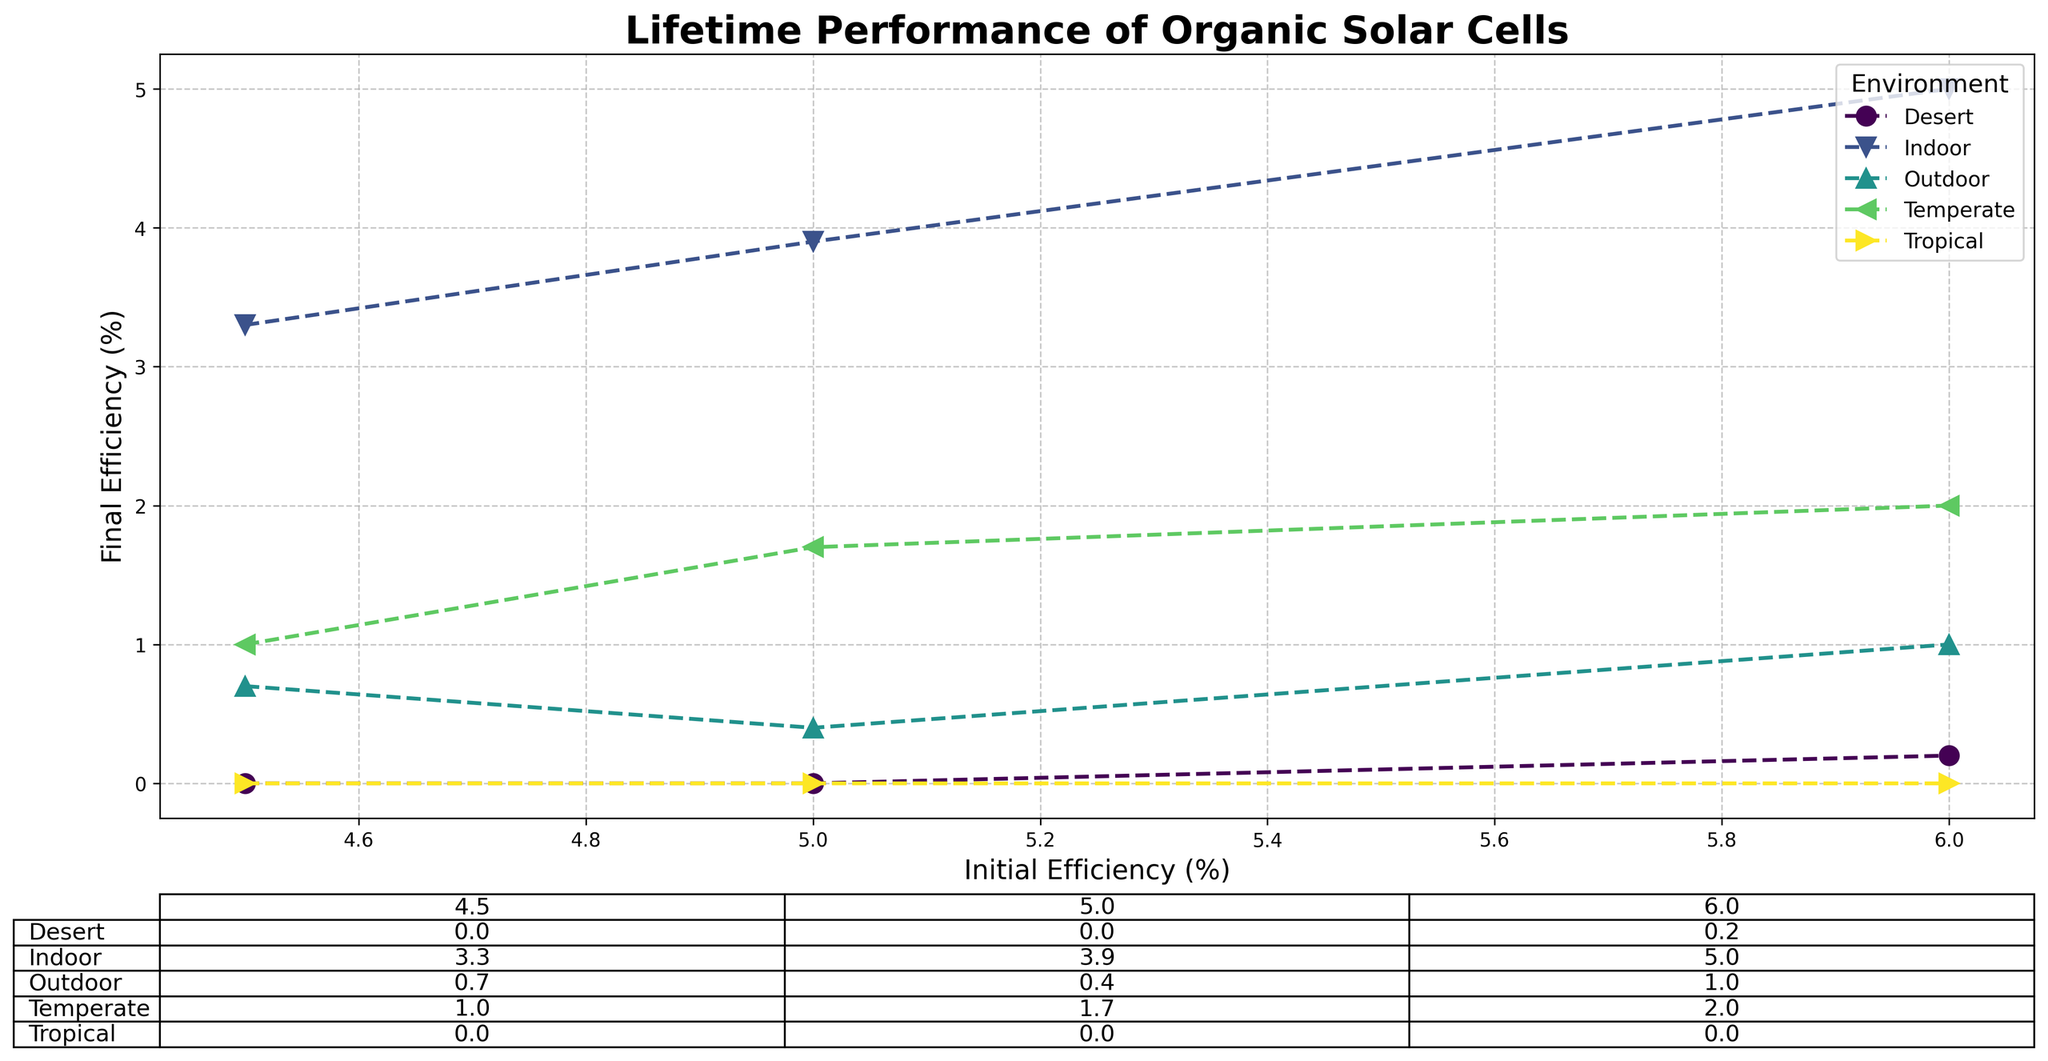What is the final efficiency of organic solar cells in a temperate environment with an initial efficiency of 6.0%? Look at the data plotted with "Temperate" and "6.0" on the x-axis and find the corresponding y-value.
Answer: 2.0% Which environment has the highest final efficiency for organic solar cells with an initial efficiency of 5.0%? Compare the final efficiencies in the table for an initial efficiency of 5.0% across different environments and identify the highest value.
Answer: Indoor What is the average final efficiency of organic solar cells for indoor conditions? Find the cells under "Indoor" in the table, sum the final efficiencies, and divide by the number of entries.
Answer: (3.3 + 3.9 + 5.0) / 3 = 4.07% Which environment shows the highest degradation rate for solar cells initially at 5.0% efficiency? Compare the degradation rates listed for solar cells with 5.0% initial efficiency in different environments and identify the highest rate.
Answer: Tropical What is the difference between the final efficiency of solar cells in tropical and desert environments with an initial efficiency of 4.5%? Look at the final efficiency for "Tropical" and "Desert" with initial efficiency of 4.5% on the table, then subtract the smaller value from the larger value.
Answer: 0.0% - 0.0% = 0.0% Which environment demonstrated no remaining efficiency after 10 years for any initial efficiency values? Identify environments in the table where some columns contain only "0.0" values for final efficiency.
Answer: Tropical, Desert How does the final efficiency of solar cells with initial efficiencies of 4.5% and 6.0% compare in an outdoor environment? Compare the final efficiencies of solar cells specified for "Outdoor" with initial efficiencies of 4.5% and 6.0% and identify which is higher.
Answer: 6.0% initial - 1.0%; 4.5% initial - 0.7%; 1.0% is higher What is the median final efficiency of solar cells in a temperate environment? Arranging all final efficiency values regarding "Temperate" in increasing order and locate the median value if there are an odd number of entries or average the two middle values if even.
Answer: (1.0 + 1.7 + 2.0) / 3 = 1.57% Compare the degradation rate of solar cells with an initial efficiency of 6.0% in indoor and desert environments. Which is lower? Look at the degradation rates for "Indoor" and "Desert" with an initial efficiency of 6.0% and identify which rate is smaller.
Answer: Indoor: 1.0%, Desert: 5.8%; Indoor is lower What is the percentage change in final efficiency for solar cells with an initial efficiency of 5.0% in an outdoor environment? Calculate the percentage change from the initial to final efficiency using the formula [(Final - Initial) / Initial * 100].
Answer: [(0.4 - 5.0) / 5.0 * 100] = -92% 